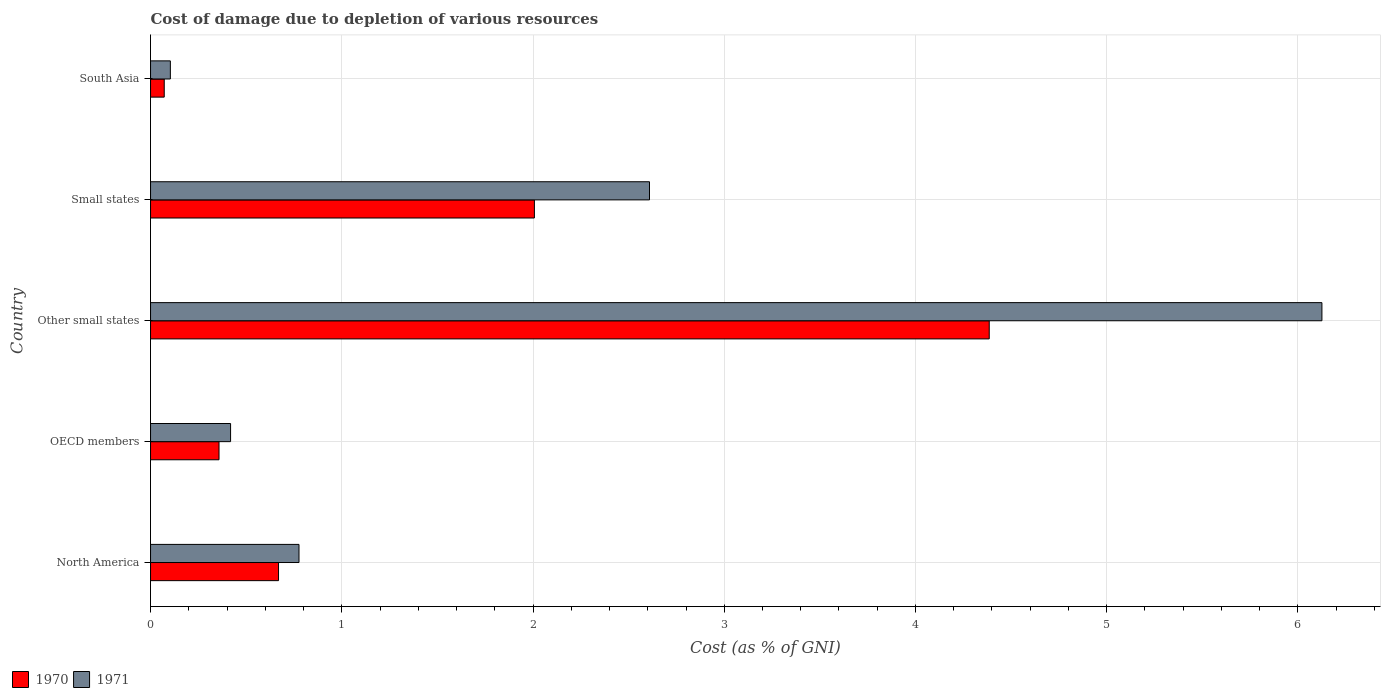How many groups of bars are there?
Your answer should be very brief. 5. Are the number of bars per tick equal to the number of legend labels?
Make the answer very short. Yes. How many bars are there on the 4th tick from the top?
Ensure brevity in your answer.  2. How many bars are there on the 1st tick from the bottom?
Give a very brief answer. 2. What is the cost of damage caused due to the depletion of various resources in 1971 in North America?
Ensure brevity in your answer.  0.78. Across all countries, what is the maximum cost of damage caused due to the depletion of various resources in 1971?
Keep it short and to the point. 6.13. Across all countries, what is the minimum cost of damage caused due to the depletion of various resources in 1970?
Offer a very short reply. 0.07. In which country was the cost of damage caused due to the depletion of various resources in 1970 maximum?
Give a very brief answer. Other small states. What is the total cost of damage caused due to the depletion of various resources in 1970 in the graph?
Offer a terse response. 7.49. What is the difference between the cost of damage caused due to the depletion of various resources in 1971 in Other small states and that in South Asia?
Keep it short and to the point. 6.02. What is the difference between the cost of damage caused due to the depletion of various resources in 1971 in OECD members and the cost of damage caused due to the depletion of various resources in 1970 in Other small states?
Make the answer very short. -3.97. What is the average cost of damage caused due to the depletion of various resources in 1970 per country?
Your response must be concise. 1.5. What is the difference between the cost of damage caused due to the depletion of various resources in 1970 and cost of damage caused due to the depletion of various resources in 1971 in OECD members?
Your answer should be compact. -0.06. What is the ratio of the cost of damage caused due to the depletion of various resources in 1971 in Other small states to that in Small states?
Provide a succinct answer. 2.35. Is the cost of damage caused due to the depletion of various resources in 1971 in OECD members less than that in South Asia?
Keep it short and to the point. No. What is the difference between the highest and the second highest cost of damage caused due to the depletion of various resources in 1971?
Give a very brief answer. 3.52. What is the difference between the highest and the lowest cost of damage caused due to the depletion of various resources in 1970?
Provide a short and direct response. 4.31. In how many countries, is the cost of damage caused due to the depletion of various resources in 1970 greater than the average cost of damage caused due to the depletion of various resources in 1970 taken over all countries?
Your response must be concise. 2. Is the sum of the cost of damage caused due to the depletion of various resources in 1970 in OECD members and Small states greater than the maximum cost of damage caused due to the depletion of various resources in 1971 across all countries?
Provide a short and direct response. No. Are all the bars in the graph horizontal?
Your answer should be very brief. Yes. Does the graph contain any zero values?
Make the answer very short. No. Does the graph contain grids?
Make the answer very short. Yes. Where does the legend appear in the graph?
Ensure brevity in your answer.  Bottom left. What is the title of the graph?
Your answer should be very brief. Cost of damage due to depletion of various resources. What is the label or title of the X-axis?
Your answer should be very brief. Cost (as % of GNI). What is the label or title of the Y-axis?
Ensure brevity in your answer.  Country. What is the Cost (as % of GNI) in 1970 in North America?
Make the answer very short. 0.67. What is the Cost (as % of GNI) of 1971 in North America?
Offer a very short reply. 0.78. What is the Cost (as % of GNI) of 1970 in OECD members?
Offer a terse response. 0.36. What is the Cost (as % of GNI) in 1971 in OECD members?
Your answer should be compact. 0.42. What is the Cost (as % of GNI) of 1970 in Other small states?
Offer a terse response. 4.39. What is the Cost (as % of GNI) in 1971 in Other small states?
Provide a succinct answer. 6.13. What is the Cost (as % of GNI) of 1970 in Small states?
Your answer should be compact. 2.01. What is the Cost (as % of GNI) of 1971 in Small states?
Give a very brief answer. 2.61. What is the Cost (as % of GNI) of 1970 in South Asia?
Your answer should be very brief. 0.07. What is the Cost (as % of GNI) of 1971 in South Asia?
Your answer should be very brief. 0.1. Across all countries, what is the maximum Cost (as % of GNI) in 1970?
Your answer should be very brief. 4.39. Across all countries, what is the maximum Cost (as % of GNI) in 1971?
Your response must be concise. 6.13. Across all countries, what is the minimum Cost (as % of GNI) in 1970?
Offer a very short reply. 0.07. Across all countries, what is the minimum Cost (as % of GNI) of 1971?
Offer a terse response. 0.1. What is the total Cost (as % of GNI) in 1970 in the graph?
Offer a very short reply. 7.49. What is the total Cost (as % of GNI) of 1971 in the graph?
Give a very brief answer. 10.03. What is the difference between the Cost (as % of GNI) of 1970 in North America and that in OECD members?
Provide a short and direct response. 0.31. What is the difference between the Cost (as % of GNI) in 1971 in North America and that in OECD members?
Offer a terse response. 0.36. What is the difference between the Cost (as % of GNI) of 1970 in North America and that in Other small states?
Provide a succinct answer. -3.72. What is the difference between the Cost (as % of GNI) in 1971 in North America and that in Other small states?
Make the answer very short. -5.35. What is the difference between the Cost (as % of GNI) of 1970 in North America and that in Small states?
Give a very brief answer. -1.34. What is the difference between the Cost (as % of GNI) of 1971 in North America and that in Small states?
Your answer should be compact. -1.83. What is the difference between the Cost (as % of GNI) in 1970 in North America and that in South Asia?
Offer a very short reply. 0.6. What is the difference between the Cost (as % of GNI) of 1971 in North America and that in South Asia?
Offer a terse response. 0.67. What is the difference between the Cost (as % of GNI) in 1970 in OECD members and that in Other small states?
Your response must be concise. -4.03. What is the difference between the Cost (as % of GNI) in 1971 in OECD members and that in Other small states?
Provide a succinct answer. -5.71. What is the difference between the Cost (as % of GNI) in 1970 in OECD members and that in Small states?
Your answer should be compact. -1.65. What is the difference between the Cost (as % of GNI) of 1971 in OECD members and that in Small states?
Your answer should be compact. -2.19. What is the difference between the Cost (as % of GNI) in 1970 in OECD members and that in South Asia?
Provide a succinct answer. 0.29. What is the difference between the Cost (as % of GNI) in 1971 in OECD members and that in South Asia?
Your answer should be compact. 0.31. What is the difference between the Cost (as % of GNI) in 1970 in Other small states and that in Small states?
Ensure brevity in your answer.  2.38. What is the difference between the Cost (as % of GNI) of 1971 in Other small states and that in Small states?
Give a very brief answer. 3.52. What is the difference between the Cost (as % of GNI) of 1970 in Other small states and that in South Asia?
Provide a succinct answer. 4.31. What is the difference between the Cost (as % of GNI) in 1971 in Other small states and that in South Asia?
Ensure brevity in your answer.  6.02. What is the difference between the Cost (as % of GNI) in 1970 in Small states and that in South Asia?
Your answer should be very brief. 1.94. What is the difference between the Cost (as % of GNI) of 1971 in Small states and that in South Asia?
Your answer should be very brief. 2.51. What is the difference between the Cost (as % of GNI) of 1970 in North America and the Cost (as % of GNI) of 1971 in OECD members?
Your response must be concise. 0.25. What is the difference between the Cost (as % of GNI) in 1970 in North America and the Cost (as % of GNI) in 1971 in Other small states?
Your answer should be compact. -5.46. What is the difference between the Cost (as % of GNI) in 1970 in North America and the Cost (as % of GNI) in 1971 in Small states?
Your response must be concise. -1.94. What is the difference between the Cost (as % of GNI) of 1970 in North America and the Cost (as % of GNI) of 1971 in South Asia?
Ensure brevity in your answer.  0.57. What is the difference between the Cost (as % of GNI) in 1970 in OECD members and the Cost (as % of GNI) in 1971 in Other small states?
Make the answer very short. -5.77. What is the difference between the Cost (as % of GNI) in 1970 in OECD members and the Cost (as % of GNI) in 1971 in Small states?
Provide a succinct answer. -2.25. What is the difference between the Cost (as % of GNI) of 1970 in OECD members and the Cost (as % of GNI) of 1971 in South Asia?
Make the answer very short. 0.25. What is the difference between the Cost (as % of GNI) in 1970 in Other small states and the Cost (as % of GNI) in 1971 in Small states?
Provide a succinct answer. 1.78. What is the difference between the Cost (as % of GNI) in 1970 in Other small states and the Cost (as % of GNI) in 1971 in South Asia?
Make the answer very short. 4.28. What is the difference between the Cost (as % of GNI) in 1970 in Small states and the Cost (as % of GNI) in 1971 in South Asia?
Your answer should be compact. 1.9. What is the average Cost (as % of GNI) in 1970 per country?
Offer a very short reply. 1.5. What is the average Cost (as % of GNI) of 1971 per country?
Make the answer very short. 2.01. What is the difference between the Cost (as % of GNI) in 1970 and Cost (as % of GNI) in 1971 in North America?
Provide a succinct answer. -0.11. What is the difference between the Cost (as % of GNI) of 1970 and Cost (as % of GNI) of 1971 in OECD members?
Give a very brief answer. -0.06. What is the difference between the Cost (as % of GNI) of 1970 and Cost (as % of GNI) of 1971 in Other small states?
Provide a succinct answer. -1.74. What is the difference between the Cost (as % of GNI) in 1970 and Cost (as % of GNI) in 1971 in Small states?
Make the answer very short. -0.6. What is the difference between the Cost (as % of GNI) in 1970 and Cost (as % of GNI) in 1971 in South Asia?
Your answer should be compact. -0.03. What is the ratio of the Cost (as % of GNI) in 1970 in North America to that in OECD members?
Your answer should be very brief. 1.87. What is the ratio of the Cost (as % of GNI) in 1971 in North America to that in OECD members?
Ensure brevity in your answer.  1.85. What is the ratio of the Cost (as % of GNI) in 1970 in North America to that in Other small states?
Your answer should be very brief. 0.15. What is the ratio of the Cost (as % of GNI) in 1971 in North America to that in Other small states?
Provide a succinct answer. 0.13. What is the ratio of the Cost (as % of GNI) of 1970 in North America to that in Small states?
Your answer should be very brief. 0.33. What is the ratio of the Cost (as % of GNI) in 1971 in North America to that in Small states?
Give a very brief answer. 0.3. What is the ratio of the Cost (as % of GNI) in 1970 in North America to that in South Asia?
Make the answer very short. 9.34. What is the ratio of the Cost (as % of GNI) of 1971 in North America to that in South Asia?
Your response must be concise. 7.49. What is the ratio of the Cost (as % of GNI) in 1970 in OECD members to that in Other small states?
Give a very brief answer. 0.08. What is the ratio of the Cost (as % of GNI) of 1971 in OECD members to that in Other small states?
Offer a terse response. 0.07. What is the ratio of the Cost (as % of GNI) of 1970 in OECD members to that in Small states?
Make the answer very short. 0.18. What is the ratio of the Cost (as % of GNI) in 1971 in OECD members to that in Small states?
Offer a terse response. 0.16. What is the ratio of the Cost (as % of GNI) in 1970 in OECD members to that in South Asia?
Your response must be concise. 5. What is the ratio of the Cost (as % of GNI) of 1971 in OECD members to that in South Asia?
Give a very brief answer. 4.04. What is the ratio of the Cost (as % of GNI) in 1970 in Other small states to that in Small states?
Make the answer very short. 2.18. What is the ratio of the Cost (as % of GNI) in 1971 in Other small states to that in Small states?
Offer a terse response. 2.35. What is the ratio of the Cost (as % of GNI) in 1970 in Other small states to that in South Asia?
Provide a short and direct response. 61.21. What is the ratio of the Cost (as % of GNI) in 1971 in Other small states to that in South Asia?
Provide a short and direct response. 59.08. What is the ratio of the Cost (as % of GNI) of 1970 in Small states to that in South Asia?
Your answer should be compact. 28.02. What is the ratio of the Cost (as % of GNI) in 1971 in Small states to that in South Asia?
Your answer should be very brief. 25.17. What is the difference between the highest and the second highest Cost (as % of GNI) in 1970?
Your answer should be very brief. 2.38. What is the difference between the highest and the second highest Cost (as % of GNI) in 1971?
Provide a succinct answer. 3.52. What is the difference between the highest and the lowest Cost (as % of GNI) of 1970?
Your answer should be compact. 4.31. What is the difference between the highest and the lowest Cost (as % of GNI) of 1971?
Keep it short and to the point. 6.02. 